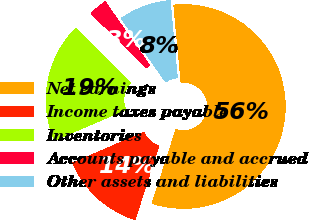Convert chart to OTSL. <chart><loc_0><loc_0><loc_500><loc_500><pie_chart><fcel>Net earnings<fcel>Income taxes payable<fcel>Inventories<fcel>Accounts payable and accrued<fcel>Other assets and liabilities<nl><fcel>56.45%<fcel>13.57%<fcel>18.93%<fcel>2.85%<fcel>8.21%<nl></chart> 